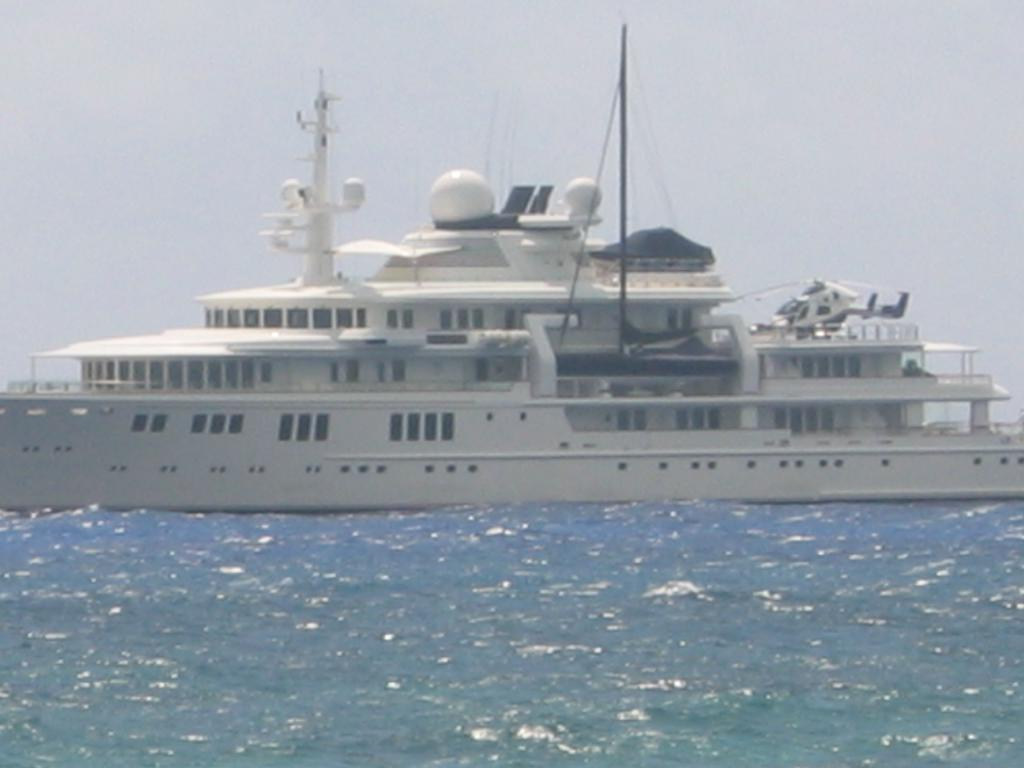What is the main subject of the image? The main subject of the image is a ship. Where is the ship located? The ship is on the water. What else can be seen in the image besides the ship? The sky is visible at the top of the image. Where is the rabbit hiding in the image? There is no rabbit present in the image. What type of store can be seen near the ship in the image? There is no store present in the image; it only features a ship on the water and the sky. 